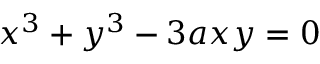Convert formula to latex. <formula><loc_0><loc_0><loc_500><loc_500>x ^ { 3 } + y ^ { 3 } - 3 a x y = 0</formula> 